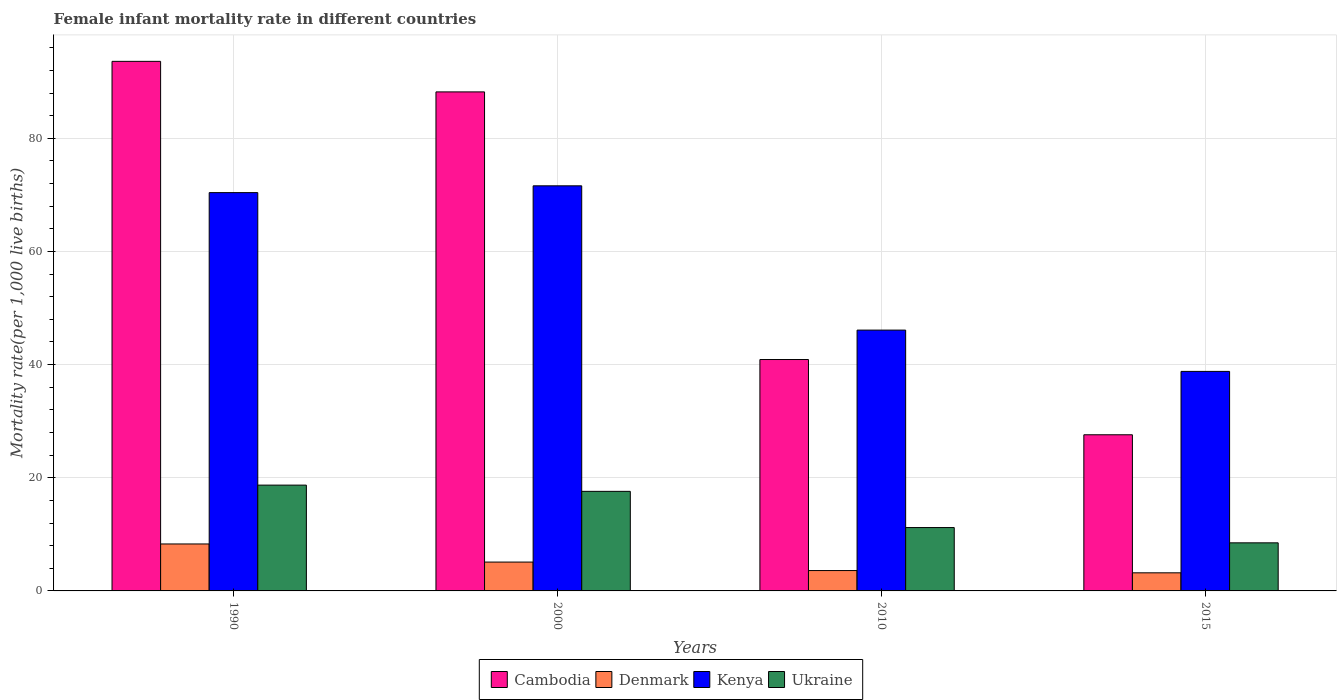Are the number of bars per tick equal to the number of legend labels?
Ensure brevity in your answer.  Yes. Are the number of bars on each tick of the X-axis equal?
Your response must be concise. Yes. What is the label of the 2nd group of bars from the left?
Offer a very short reply. 2000. What is the female infant mortality rate in Ukraine in 2010?
Your answer should be very brief. 11.2. Across all years, what is the maximum female infant mortality rate in Kenya?
Your answer should be compact. 71.6. Across all years, what is the minimum female infant mortality rate in Cambodia?
Offer a terse response. 27.6. In which year was the female infant mortality rate in Denmark maximum?
Provide a succinct answer. 1990. In which year was the female infant mortality rate in Cambodia minimum?
Offer a very short reply. 2015. What is the total female infant mortality rate in Cambodia in the graph?
Make the answer very short. 250.3. What is the difference between the female infant mortality rate in Cambodia in 1990 and that in 2000?
Your answer should be compact. 5.4. What is the difference between the female infant mortality rate in Ukraine in 2015 and the female infant mortality rate in Denmark in 1990?
Your response must be concise. 0.2. What is the average female infant mortality rate in Cambodia per year?
Provide a short and direct response. 62.58. In the year 2015, what is the difference between the female infant mortality rate in Ukraine and female infant mortality rate in Denmark?
Your answer should be very brief. 5.3. What is the ratio of the female infant mortality rate in Ukraine in 2000 to that in 2010?
Make the answer very short. 1.57. What is the difference between the highest and the second highest female infant mortality rate in Cambodia?
Offer a terse response. 5.4. What is the difference between the highest and the lowest female infant mortality rate in Cambodia?
Keep it short and to the point. 66. In how many years, is the female infant mortality rate in Cambodia greater than the average female infant mortality rate in Cambodia taken over all years?
Your answer should be compact. 2. What does the 3rd bar from the left in 2015 represents?
Provide a succinct answer. Kenya. Is it the case that in every year, the sum of the female infant mortality rate in Ukraine and female infant mortality rate in Cambodia is greater than the female infant mortality rate in Denmark?
Provide a succinct answer. Yes. Are all the bars in the graph horizontal?
Give a very brief answer. No. How many years are there in the graph?
Offer a very short reply. 4. What is the difference between two consecutive major ticks on the Y-axis?
Give a very brief answer. 20. Are the values on the major ticks of Y-axis written in scientific E-notation?
Ensure brevity in your answer.  No. Does the graph contain any zero values?
Keep it short and to the point. No. Where does the legend appear in the graph?
Give a very brief answer. Bottom center. What is the title of the graph?
Your answer should be very brief. Female infant mortality rate in different countries. What is the label or title of the Y-axis?
Offer a very short reply. Mortality rate(per 1,0 live births). What is the Mortality rate(per 1,000 live births) in Cambodia in 1990?
Your response must be concise. 93.6. What is the Mortality rate(per 1,000 live births) in Denmark in 1990?
Offer a very short reply. 8.3. What is the Mortality rate(per 1,000 live births) in Kenya in 1990?
Ensure brevity in your answer.  70.4. What is the Mortality rate(per 1,000 live births) in Ukraine in 1990?
Give a very brief answer. 18.7. What is the Mortality rate(per 1,000 live births) in Cambodia in 2000?
Provide a succinct answer. 88.2. What is the Mortality rate(per 1,000 live births) in Denmark in 2000?
Give a very brief answer. 5.1. What is the Mortality rate(per 1,000 live births) in Kenya in 2000?
Ensure brevity in your answer.  71.6. What is the Mortality rate(per 1,000 live births) in Ukraine in 2000?
Make the answer very short. 17.6. What is the Mortality rate(per 1,000 live births) in Cambodia in 2010?
Keep it short and to the point. 40.9. What is the Mortality rate(per 1,000 live births) of Denmark in 2010?
Offer a terse response. 3.6. What is the Mortality rate(per 1,000 live births) of Kenya in 2010?
Your answer should be very brief. 46.1. What is the Mortality rate(per 1,000 live births) of Cambodia in 2015?
Offer a terse response. 27.6. What is the Mortality rate(per 1,000 live births) of Kenya in 2015?
Your answer should be very brief. 38.8. What is the Mortality rate(per 1,000 live births) in Ukraine in 2015?
Make the answer very short. 8.5. Across all years, what is the maximum Mortality rate(per 1,000 live births) in Cambodia?
Keep it short and to the point. 93.6. Across all years, what is the maximum Mortality rate(per 1,000 live births) in Denmark?
Give a very brief answer. 8.3. Across all years, what is the maximum Mortality rate(per 1,000 live births) of Kenya?
Ensure brevity in your answer.  71.6. Across all years, what is the minimum Mortality rate(per 1,000 live births) in Cambodia?
Make the answer very short. 27.6. Across all years, what is the minimum Mortality rate(per 1,000 live births) of Denmark?
Provide a succinct answer. 3.2. Across all years, what is the minimum Mortality rate(per 1,000 live births) of Kenya?
Keep it short and to the point. 38.8. What is the total Mortality rate(per 1,000 live births) of Cambodia in the graph?
Offer a terse response. 250.3. What is the total Mortality rate(per 1,000 live births) of Denmark in the graph?
Make the answer very short. 20.2. What is the total Mortality rate(per 1,000 live births) in Kenya in the graph?
Provide a short and direct response. 226.9. What is the total Mortality rate(per 1,000 live births) in Ukraine in the graph?
Your response must be concise. 56. What is the difference between the Mortality rate(per 1,000 live births) of Cambodia in 1990 and that in 2000?
Your answer should be very brief. 5.4. What is the difference between the Mortality rate(per 1,000 live births) of Cambodia in 1990 and that in 2010?
Keep it short and to the point. 52.7. What is the difference between the Mortality rate(per 1,000 live births) in Denmark in 1990 and that in 2010?
Your response must be concise. 4.7. What is the difference between the Mortality rate(per 1,000 live births) in Kenya in 1990 and that in 2010?
Your answer should be very brief. 24.3. What is the difference between the Mortality rate(per 1,000 live births) in Kenya in 1990 and that in 2015?
Offer a terse response. 31.6. What is the difference between the Mortality rate(per 1,000 live births) of Cambodia in 2000 and that in 2010?
Give a very brief answer. 47.3. What is the difference between the Mortality rate(per 1,000 live births) in Cambodia in 2000 and that in 2015?
Offer a terse response. 60.6. What is the difference between the Mortality rate(per 1,000 live births) in Denmark in 2000 and that in 2015?
Keep it short and to the point. 1.9. What is the difference between the Mortality rate(per 1,000 live births) in Kenya in 2000 and that in 2015?
Provide a short and direct response. 32.8. What is the difference between the Mortality rate(per 1,000 live births) in Cambodia in 2010 and that in 2015?
Your response must be concise. 13.3. What is the difference between the Mortality rate(per 1,000 live births) in Ukraine in 2010 and that in 2015?
Give a very brief answer. 2.7. What is the difference between the Mortality rate(per 1,000 live births) of Cambodia in 1990 and the Mortality rate(per 1,000 live births) of Denmark in 2000?
Offer a terse response. 88.5. What is the difference between the Mortality rate(per 1,000 live births) of Denmark in 1990 and the Mortality rate(per 1,000 live births) of Kenya in 2000?
Offer a terse response. -63.3. What is the difference between the Mortality rate(per 1,000 live births) of Kenya in 1990 and the Mortality rate(per 1,000 live births) of Ukraine in 2000?
Your answer should be very brief. 52.8. What is the difference between the Mortality rate(per 1,000 live births) of Cambodia in 1990 and the Mortality rate(per 1,000 live births) of Kenya in 2010?
Give a very brief answer. 47.5. What is the difference between the Mortality rate(per 1,000 live births) of Cambodia in 1990 and the Mortality rate(per 1,000 live births) of Ukraine in 2010?
Keep it short and to the point. 82.4. What is the difference between the Mortality rate(per 1,000 live births) of Denmark in 1990 and the Mortality rate(per 1,000 live births) of Kenya in 2010?
Your response must be concise. -37.8. What is the difference between the Mortality rate(per 1,000 live births) in Denmark in 1990 and the Mortality rate(per 1,000 live births) in Ukraine in 2010?
Offer a very short reply. -2.9. What is the difference between the Mortality rate(per 1,000 live births) in Kenya in 1990 and the Mortality rate(per 1,000 live births) in Ukraine in 2010?
Offer a very short reply. 59.2. What is the difference between the Mortality rate(per 1,000 live births) of Cambodia in 1990 and the Mortality rate(per 1,000 live births) of Denmark in 2015?
Provide a short and direct response. 90.4. What is the difference between the Mortality rate(per 1,000 live births) in Cambodia in 1990 and the Mortality rate(per 1,000 live births) in Kenya in 2015?
Give a very brief answer. 54.8. What is the difference between the Mortality rate(per 1,000 live births) in Cambodia in 1990 and the Mortality rate(per 1,000 live births) in Ukraine in 2015?
Keep it short and to the point. 85.1. What is the difference between the Mortality rate(per 1,000 live births) of Denmark in 1990 and the Mortality rate(per 1,000 live births) of Kenya in 2015?
Provide a short and direct response. -30.5. What is the difference between the Mortality rate(per 1,000 live births) in Kenya in 1990 and the Mortality rate(per 1,000 live births) in Ukraine in 2015?
Offer a very short reply. 61.9. What is the difference between the Mortality rate(per 1,000 live births) in Cambodia in 2000 and the Mortality rate(per 1,000 live births) in Denmark in 2010?
Provide a short and direct response. 84.6. What is the difference between the Mortality rate(per 1,000 live births) in Cambodia in 2000 and the Mortality rate(per 1,000 live births) in Kenya in 2010?
Offer a terse response. 42.1. What is the difference between the Mortality rate(per 1,000 live births) in Denmark in 2000 and the Mortality rate(per 1,000 live births) in Kenya in 2010?
Ensure brevity in your answer.  -41. What is the difference between the Mortality rate(per 1,000 live births) of Denmark in 2000 and the Mortality rate(per 1,000 live births) of Ukraine in 2010?
Your answer should be very brief. -6.1. What is the difference between the Mortality rate(per 1,000 live births) in Kenya in 2000 and the Mortality rate(per 1,000 live births) in Ukraine in 2010?
Your response must be concise. 60.4. What is the difference between the Mortality rate(per 1,000 live births) of Cambodia in 2000 and the Mortality rate(per 1,000 live births) of Kenya in 2015?
Offer a terse response. 49.4. What is the difference between the Mortality rate(per 1,000 live births) in Cambodia in 2000 and the Mortality rate(per 1,000 live births) in Ukraine in 2015?
Ensure brevity in your answer.  79.7. What is the difference between the Mortality rate(per 1,000 live births) of Denmark in 2000 and the Mortality rate(per 1,000 live births) of Kenya in 2015?
Your answer should be compact. -33.7. What is the difference between the Mortality rate(per 1,000 live births) of Denmark in 2000 and the Mortality rate(per 1,000 live births) of Ukraine in 2015?
Provide a short and direct response. -3.4. What is the difference between the Mortality rate(per 1,000 live births) in Kenya in 2000 and the Mortality rate(per 1,000 live births) in Ukraine in 2015?
Provide a succinct answer. 63.1. What is the difference between the Mortality rate(per 1,000 live births) in Cambodia in 2010 and the Mortality rate(per 1,000 live births) in Denmark in 2015?
Provide a short and direct response. 37.7. What is the difference between the Mortality rate(per 1,000 live births) of Cambodia in 2010 and the Mortality rate(per 1,000 live births) of Kenya in 2015?
Give a very brief answer. 2.1. What is the difference between the Mortality rate(per 1,000 live births) in Cambodia in 2010 and the Mortality rate(per 1,000 live births) in Ukraine in 2015?
Give a very brief answer. 32.4. What is the difference between the Mortality rate(per 1,000 live births) of Denmark in 2010 and the Mortality rate(per 1,000 live births) of Kenya in 2015?
Your response must be concise. -35.2. What is the difference between the Mortality rate(per 1,000 live births) of Kenya in 2010 and the Mortality rate(per 1,000 live births) of Ukraine in 2015?
Give a very brief answer. 37.6. What is the average Mortality rate(per 1,000 live births) of Cambodia per year?
Keep it short and to the point. 62.58. What is the average Mortality rate(per 1,000 live births) in Denmark per year?
Keep it short and to the point. 5.05. What is the average Mortality rate(per 1,000 live births) of Kenya per year?
Keep it short and to the point. 56.73. What is the average Mortality rate(per 1,000 live births) of Ukraine per year?
Keep it short and to the point. 14. In the year 1990, what is the difference between the Mortality rate(per 1,000 live births) of Cambodia and Mortality rate(per 1,000 live births) of Denmark?
Provide a succinct answer. 85.3. In the year 1990, what is the difference between the Mortality rate(per 1,000 live births) of Cambodia and Mortality rate(per 1,000 live births) of Kenya?
Offer a very short reply. 23.2. In the year 1990, what is the difference between the Mortality rate(per 1,000 live births) of Cambodia and Mortality rate(per 1,000 live births) of Ukraine?
Give a very brief answer. 74.9. In the year 1990, what is the difference between the Mortality rate(per 1,000 live births) in Denmark and Mortality rate(per 1,000 live births) in Kenya?
Keep it short and to the point. -62.1. In the year 1990, what is the difference between the Mortality rate(per 1,000 live births) in Kenya and Mortality rate(per 1,000 live births) in Ukraine?
Provide a succinct answer. 51.7. In the year 2000, what is the difference between the Mortality rate(per 1,000 live births) of Cambodia and Mortality rate(per 1,000 live births) of Denmark?
Offer a very short reply. 83.1. In the year 2000, what is the difference between the Mortality rate(per 1,000 live births) of Cambodia and Mortality rate(per 1,000 live births) of Ukraine?
Your answer should be compact. 70.6. In the year 2000, what is the difference between the Mortality rate(per 1,000 live births) of Denmark and Mortality rate(per 1,000 live births) of Kenya?
Keep it short and to the point. -66.5. In the year 2010, what is the difference between the Mortality rate(per 1,000 live births) of Cambodia and Mortality rate(per 1,000 live births) of Denmark?
Provide a succinct answer. 37.3. In the year 2010, what is the difference between the Mortality rate(per 1,000 live births) of Cambodia and Mortality rate(per 1,000 live births) of Ukraine?
Give a very brief answer. 29.7. In the year 2010, what is the difference between the Mortality rate(per 1,000 live births) of Denmark and Mortality rate(per 1,000 live births) of Kenya?
Your response must be concise. -42.5. In the year 2010, what is the difference between the Mortality rate(per 1,000 live births) of Kenya and Mortality rate(per 1,000 live births) of Ukraine?
Keep it short and to the point. 34.9. In the year 2015, what is the difference between the Mortality rate(per 1,000 live births) in Cambodia and Mortality rate(per 1,000 live births) in Denmark?
Offer a terse response. 24.4. In the year 2015, what is the difference between the Mortality rate(per 1,000 live births) in Cambodia and Mortality rate(per 1,000 live births) in Kenya?
Ensure brevity in your answer.  -11.2. In the year 2015, what is the difference between the Mortality rate(per 1,000 live births) of Denmark and Mortality rate(per 1,000 live births) of Kenya?
Your answer should be very brief. -35.6. In the year 2015, what is the difference between the Mortality rate(per 1,000 live births) in Kenya and Mortality rate(per 1,000 live births) in Ukraine?
Offer a very short reply. 30.3. What is the ratio of the Mortality rate(per 1,000 live births) of Cambodia in 1990 to that in 2000?
Ensure brevity in your answer.  1.06. What is the ratio of the Mortality rate(per 1,000 live births) in Denmark in 1990 to that in 2000?
Provide a short and direct response. 1.63. What is the ratio of the Mortality rate(per 1,000 live births) in Kenya in 1990 to that in 2000?
Provide a short and direct response. 0.98. What is the ratio of the Mortality rate(per 1,000 live births) in Ukraine in 1990 to that in 2000?
Provide a succinct answer. 1.06. What is the ratio of the Mortality rate(per 1,000 live births) in Cambodia in 1990 to that in 2010?
Give a very brief answer. 2.29. What is the ratio of the Mortality rate(per 1,000 live births) in Denmark in 1990 to that in 2010?
Offer a very short reply. 2.31. What is the ratio of the Mortality rate(per 1,000 live births) in Kenya in 1990 to that in 2010?
Your response must be concise. 1.53. What is the ratio of the Mortality rate(per 1,000 live births) in Ukraine in 1990 to that in 2010?
Your answer should be compact. 1.67. What is the ratio of the Mortality rate(per 1,000 live births) in Cambodia in 1990 to that in 2015?
Offer a terse response. 3.39. What is the ratio of the Mortality rate(per 1,000 live births) of Denmark in 1990 to that in 2015?
Your answer should be very brief. 2.59. What is the ratio of the Mortality rate(per 1,000 live births) in Kenya in 1990 to that in 2015?
Your answer should be very brief. 1.81. What is the ratio of the Mortality rate(per 1,000 live births) in Cambodia in 2000 to that in 2010?
Your response must be concise. 2.16. What is the ratio of the Mortality rate(per 1,000 live births) in Denmark in 2000 to that in 2010?
Keep it short and to the point. 1.42. What is the ratio of the Mortality rate(per 1,000 live births) of Kenya in 2000 to that in 2010?
Offer a terse response. 1.55. What is the ratio of the Mortality rate(per 1,000 live births) in Ukraine in 2000 to that in 2010?
Offer a very short reply. 1.57. What is the ratio of the Mortality rate(per 1,000 live births) in Cambodia in 2000 to that in 2015?
Your response must be concise. 3.2. What is the ratio of the Mortality rate(per 1,000 live births) of Denmark in 2000 to that in 2015?
Provide a short and direct response. 1.59. What is the ratio of the Mortality rate(per 1,000 live births) of Kenya in 2000 to that in 2015?
Your answer should be very brief. 1.85. What is the ratio of the Mortality rate(per 1,000 live births) in Ukraine in 2000 to that in 2015?
Provide a succinct answer. 2.07. What is the ratio of the Mortality rate(per 1,000 live births) of Cambodia in 2010 to that in 2015?
Make the answer very short. 1.48. What is the ratio of the Mortality rate(per 1,000 live births) in Kenya in 2010 to that in 2015?
Offer a terse response. 1.19. What is the ratio of the Mortality rate(per 1,000 live births) in Ukraine in 2010 to that in 2015?
Provide a short and direct response. 1.32. What is the difference between the highest and the second highest Mortality rate(per 1,000 live births) of Denmark?
Provide a short and direct response. 3.2. What is the difference between the highest and the lowest Mortality rate(per 1,000 live births) of Kenya?
Offer a terse response. 32.8. 